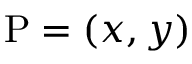Convert formula to latex. <formula><loc_0><loc_0><loc_500><loc_500>P = ( x , y )</formula> 